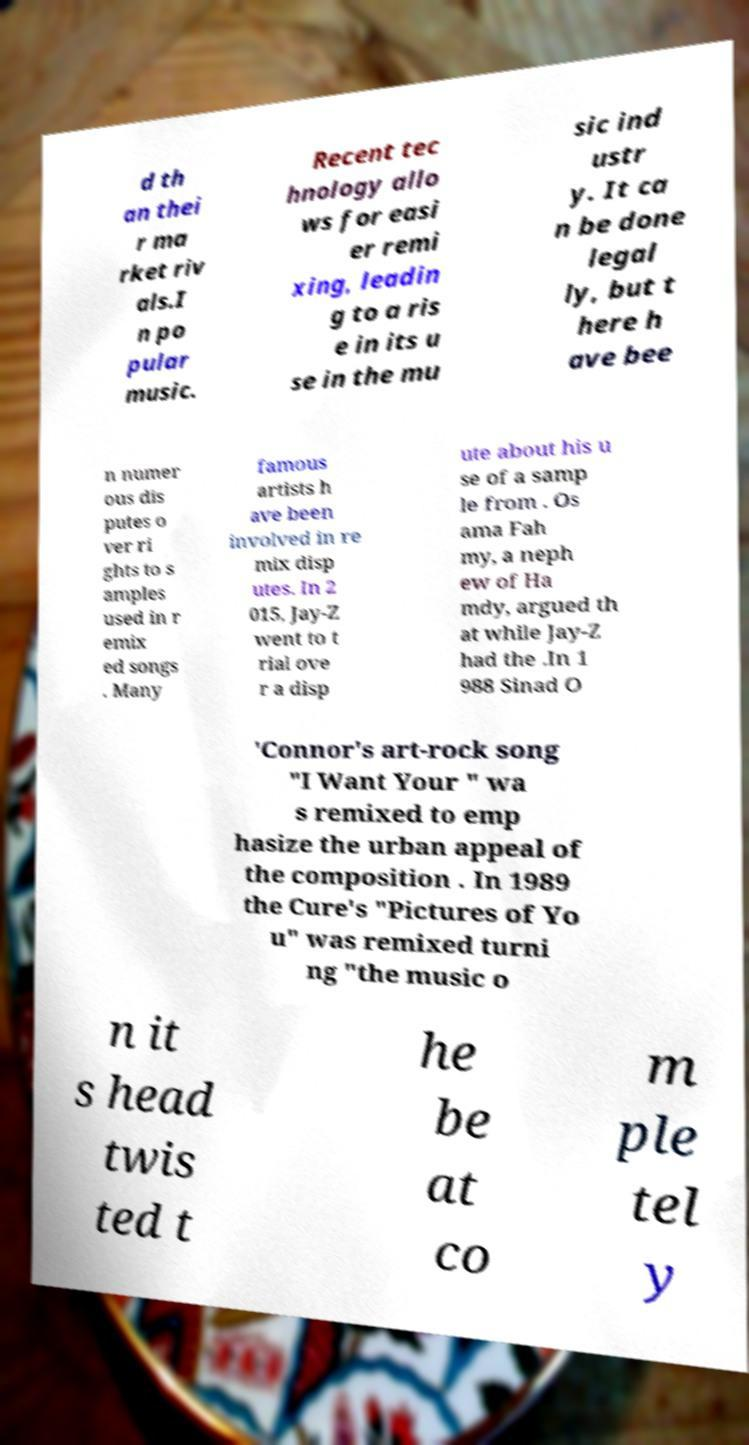Please identify and transcribe the text found in this image. d th an thei r ma rket riv als.I n po pular music. Recent tec hnology allo ws for easi er remi xing, leadin g to a ris e in its u se in the mu sic ind ustr y. It ca n be done legal ly, but t here h ave bee n numer ous dis putes o ver ri ghts to s amples used in r emix ed songs . Many famous artists h ave been involved in re mix disp utes. In 2 015, Jay-Z went to t rial ove r a disp ute about his u se of a samp le from . Os ama Fah my, a neph ew of Ha mdy, argued th at while Jay-Z had the .In 1 988 Sinad O 'Connor's art-rock song "I Want Your " wa s remixed to emp hasize the urban appeal of the composition . In 1989 the Cure's "Pictures of Yo u" was remixed turni ng "the music o n it s head twis ted t he be at co m ple tel y 